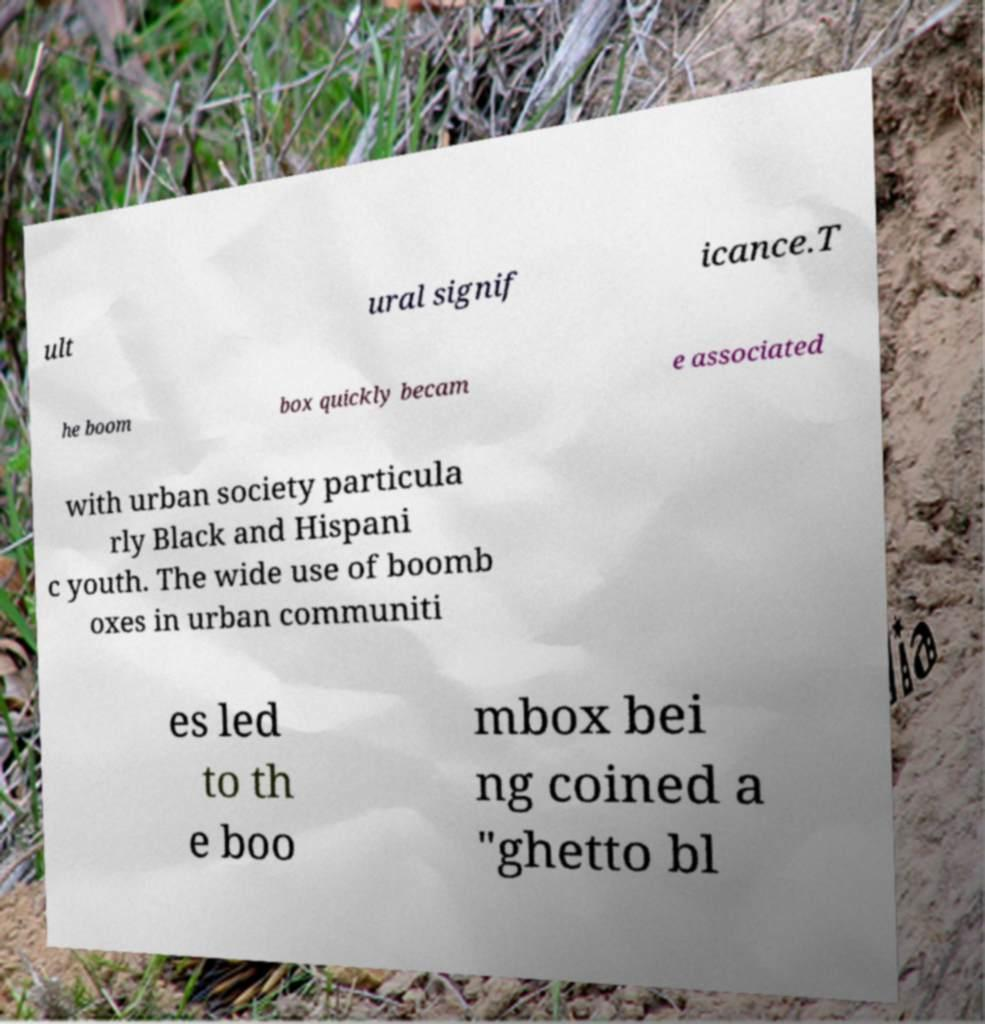There's text embedded in this image that I need extracted. Can you transcribe it verbatim? ult ural signif icance.T he boom box quickly becam e associated with urban society particula rly Black and Hispani c youth. The wide use of boomb oxes in urban communiti es led to th e boo mbox bei ng coined a "ghetto bl 